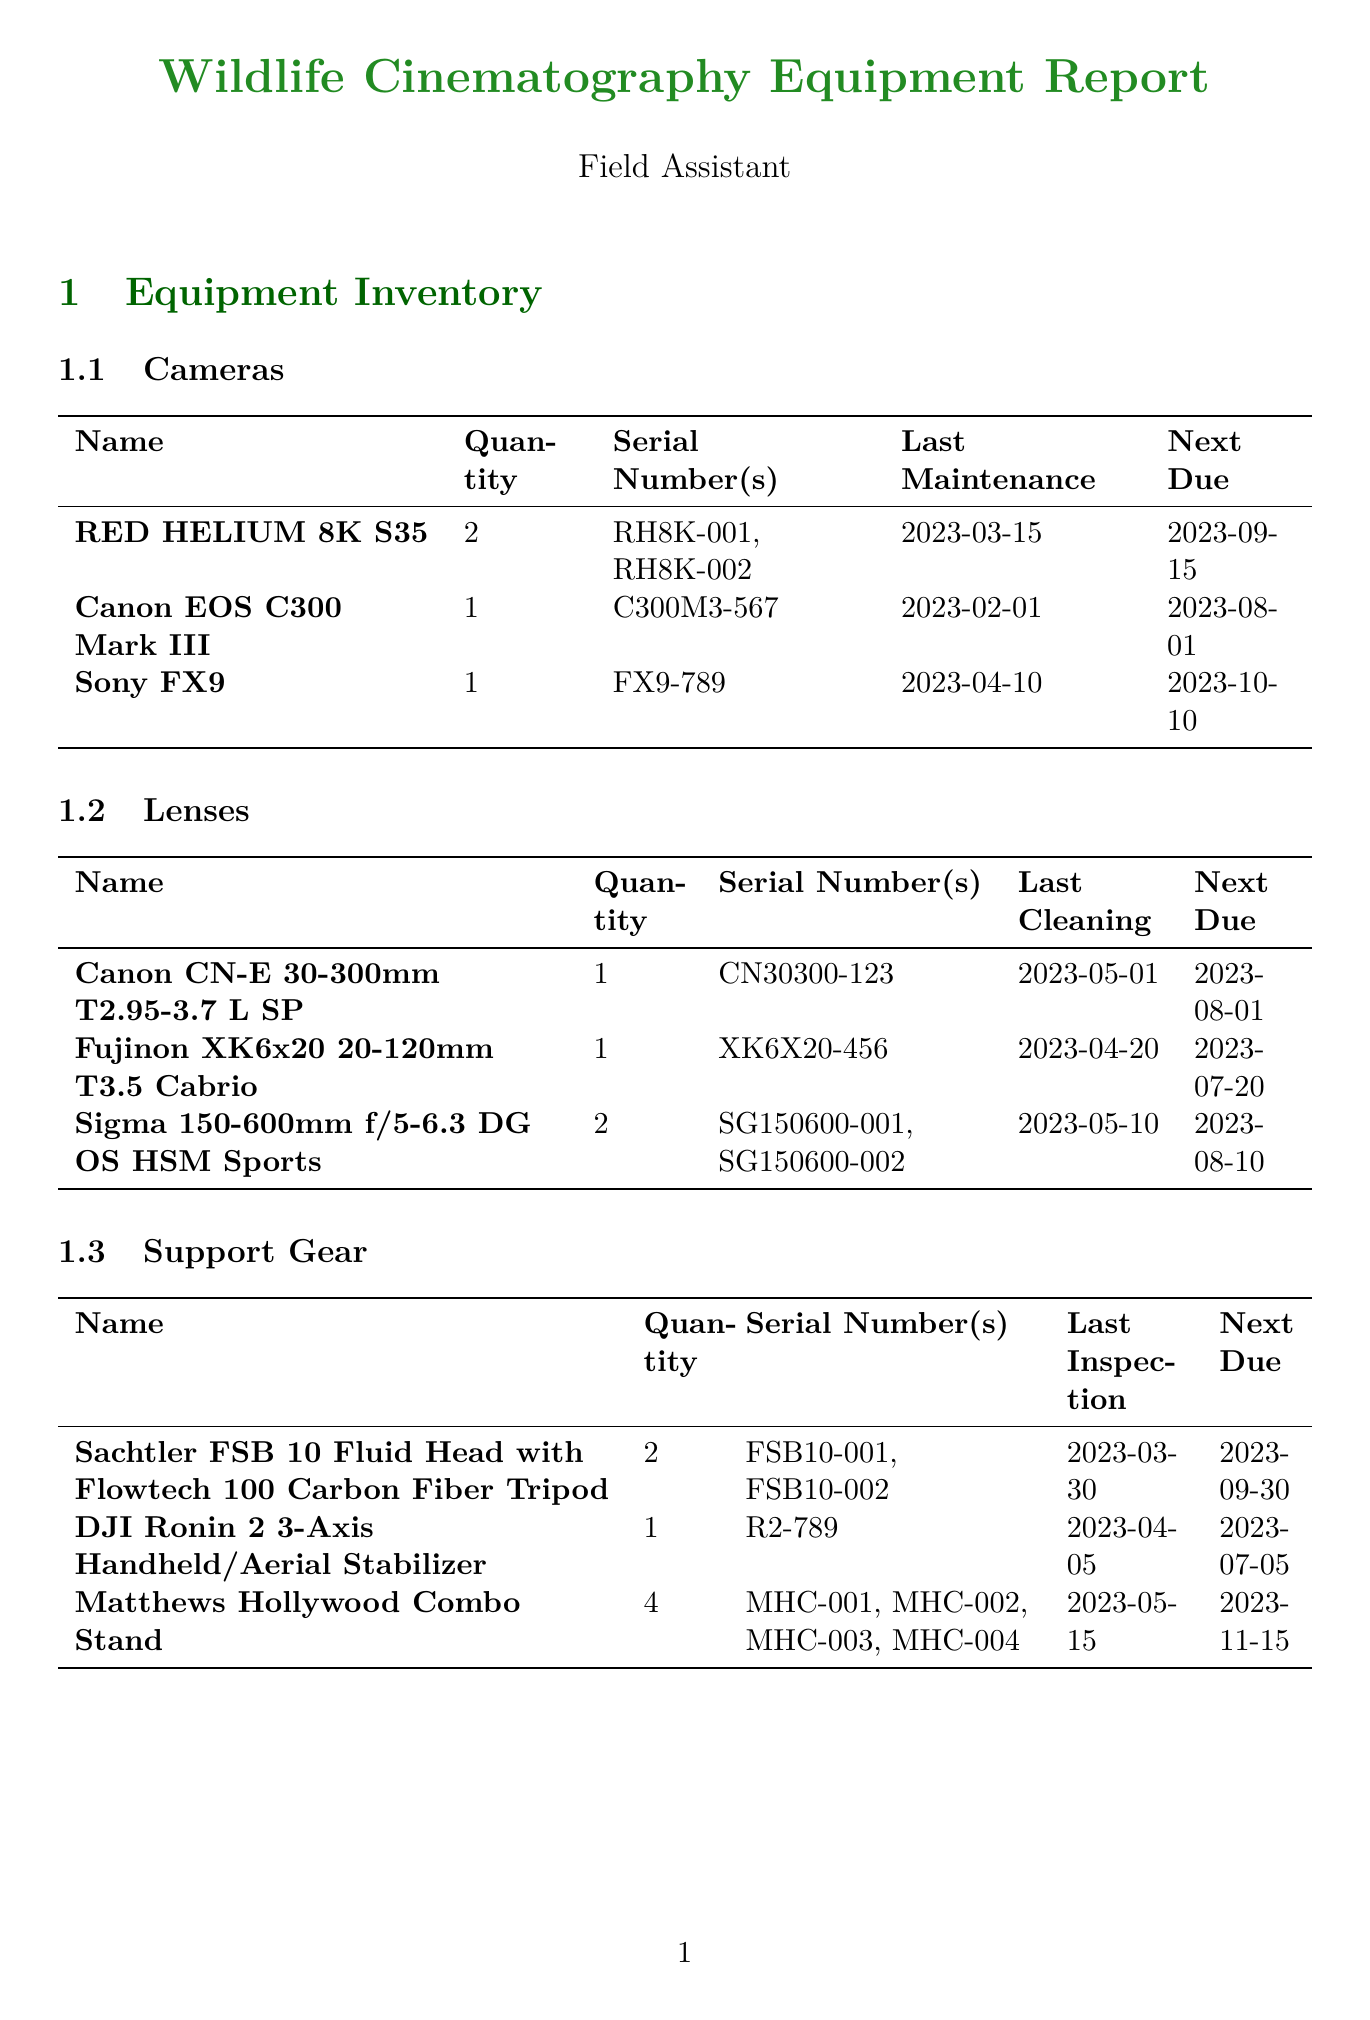What is the quantity of Canon EOS C300 Mark III? The document lists the quantity of Canon EOS C300 Mark III under the cameras section, which is 1.
Answer: 1 What is the next maintenance due date for the Sony FX9? The next maintenance due date for the Sony FX9 is found in the camera inventory, which states October 10, 2023.
Answer: 2023-10-10 How many Sigma 150-600mm lenses are listed in the inventory? The inventory mentions that there are 2 Sigma 150-600mm lenses included in the lenses section.
Answer: 2 Who performed maintenance on the DJI Ronin 2? In the maintenance log, it is mentioned that Michael Wong conducted the maintenance on the DJI Ronin 2.
Answer: Michael Wong What equipment requires dust protection? The equipment considerations section lists dust protection for cameras and lenses as necessary for the Serengeti National Park location.
Answer: Cameras and lenses What date was the last inspection of the Matthews Hollywood Combo Stand? The last inspection date of the Matthews Hollywood Combo Stand, found in the support gear inventory, is May 15, 2023.
Answer: 2023-05-15 Which wildlife species were observed at Serengeti National Park? The document specifies that the wildlife species observed include Lion, Elephant, Wildebeest, and Zebra in the location scouting section.
Answer: Lion, Elephant, Wildebeest, Zebra What permits are required for filming at Serengeti National Park? The required permits are listed as the Tanzania National Parks Authority filming permit and the vehicle entry permit.
Answer: TANAPA filming permit, Vehicle entry permit 